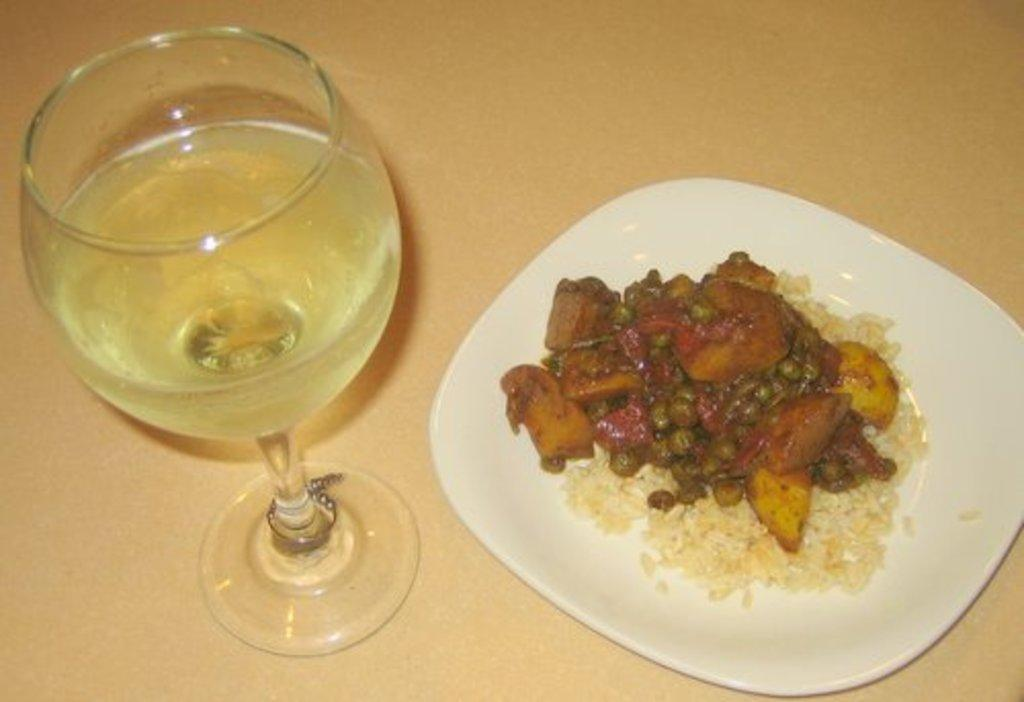What is on the right side of the image? There is a plate with food on the right side of the image. What is beside the plate? There is a glass with a drink beside the plate. Where are the plate and glass located? Both the plate and glass are placed on a table. What color are the eyes of the person holding the sign in the image? There is no person holding a sign in the image; it only features a plate with food and a glass with a drink on a table. 